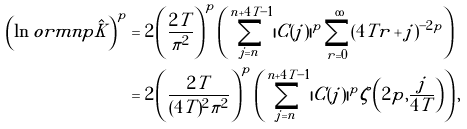<formula> <loc_0><loc_0><loc_500><loc_500>\left ( \ln o r m { n } { p } { \hat { K } } \right ) ^ { p } & = 2 \left ( \frac { 2 T } { \pi ^ { 2 } } \right ) ^ { p } \left ( \sum _ { j = n } ^ { n + 4 T - 1 } | C ( j ) | ^ { p } \sum _ { r = 0 } ^ { \infty } ( 4 T r + j ) ^ { - 2 p } \right ) \\ & = 2 \left ( \frac { 2 T } { ( 4 T ) ^ { 2 } \pi ^ { 2 } } \right ) ^ { p } \left ( \sum _ { j = n } ^ { n + 4 T - 1 } | C ( j ) | ^ { p } \zeta \left ( 2 p , \frac { j } { 4 T } \right ) \right ) ,</formula> 